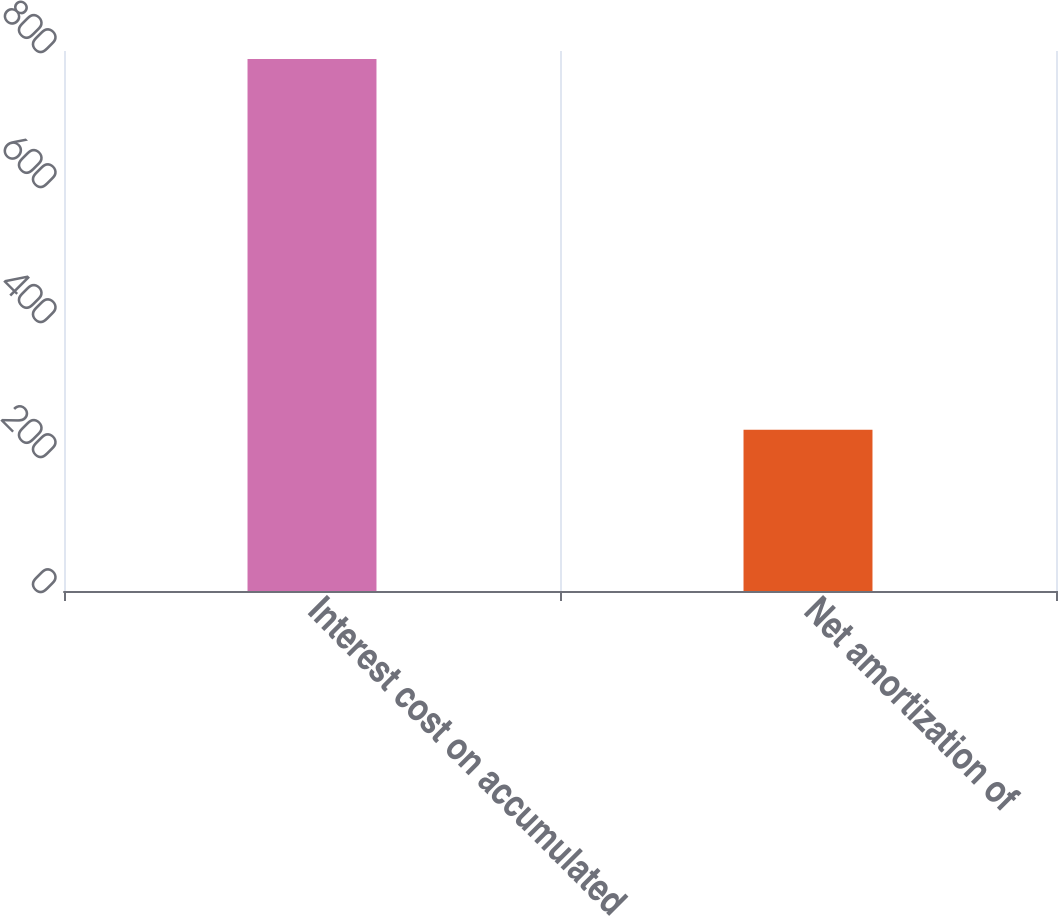Convert chart to OTSL. <chart><loc_0><loc_0><loc_500><loc_500><bar_chart><fcel>Interest cost on accumulated<fcel>Net amortization of<nl><fcel>788<fcel>239<nl></chart> 